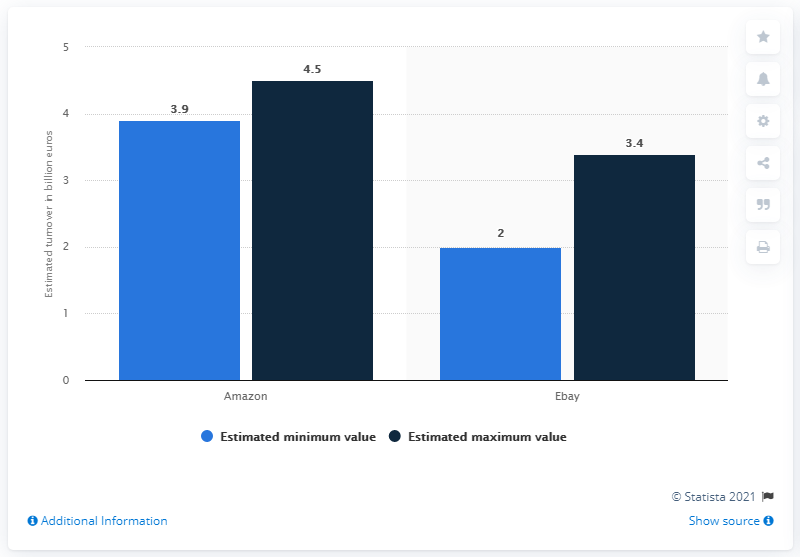List a handful of essential elements in this visual. In 2018, the estimated minimum turnover at Amazon in Italy was approximately 3.9 billion euros. According to estimates, the average eBay turnover in Italy is expected to reach a maximum of 3.4. The estimated minimum value of Amazon's revenues in Italy in 2018 was 3.9 billion euros. 